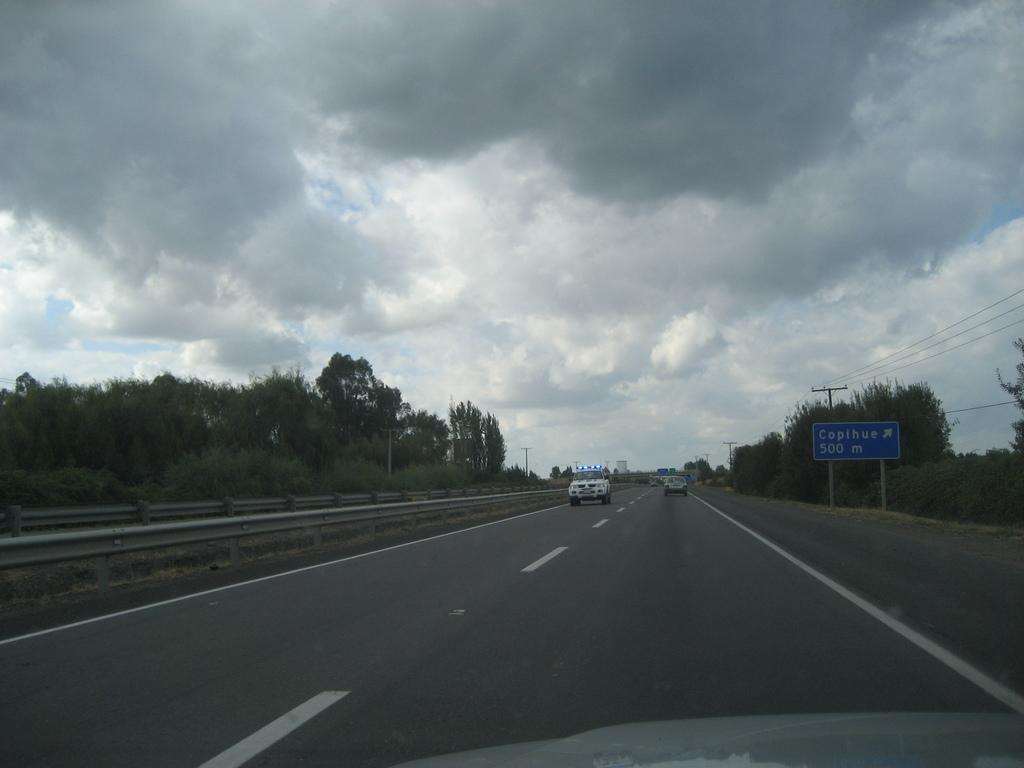What types of objects can be seen in the image? There are vehicles, trees, plants, poles, and wires in the image. What is the ground like in the image? The ground is visible in the image. What is written on the board in the image? There is a board with text in the image. What is visible in the sky in the image? There is a sky visible in the image, with clouds present. Can you tell me how many toads are sitting on the line in the image? There are no toads or lines present in the image. What breed of dog can be seen playing with the vehicles in the image? There are no dogs present in the image, and the vehicles are not being played with. 